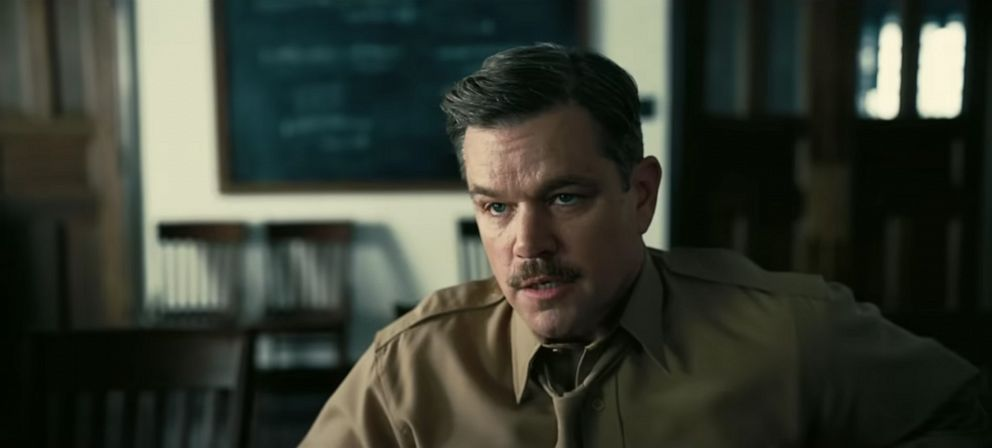Can you describe the man's emotions and possible thoughts? The man appears to be in deep contemplation, his furrowed brow and focused gaze suggesting he is processing complex information or thoughts. He seems serious and engrossed, perhaps reflecting on a significant issue or engaged in a critical conversation where every detail matters. Given the academic setting, what might be happening in this scenario? In an academic setting like this, the man could be a professor deeply involved in explaining a complex theory or problem to his students. The blackboard filled with equations hints at a subject related to mathematics or science. He could also be preparing for a lecture or critically assessing a student's project or proposal, dedicating deep thought to ensure accuracy and understanding. 